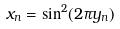<formula> <loc_0><loc_0><loc_500><loc_500>x _ { n } = \sin ^ { 2 } ( 2 \pi y _ { n } )</formula> 